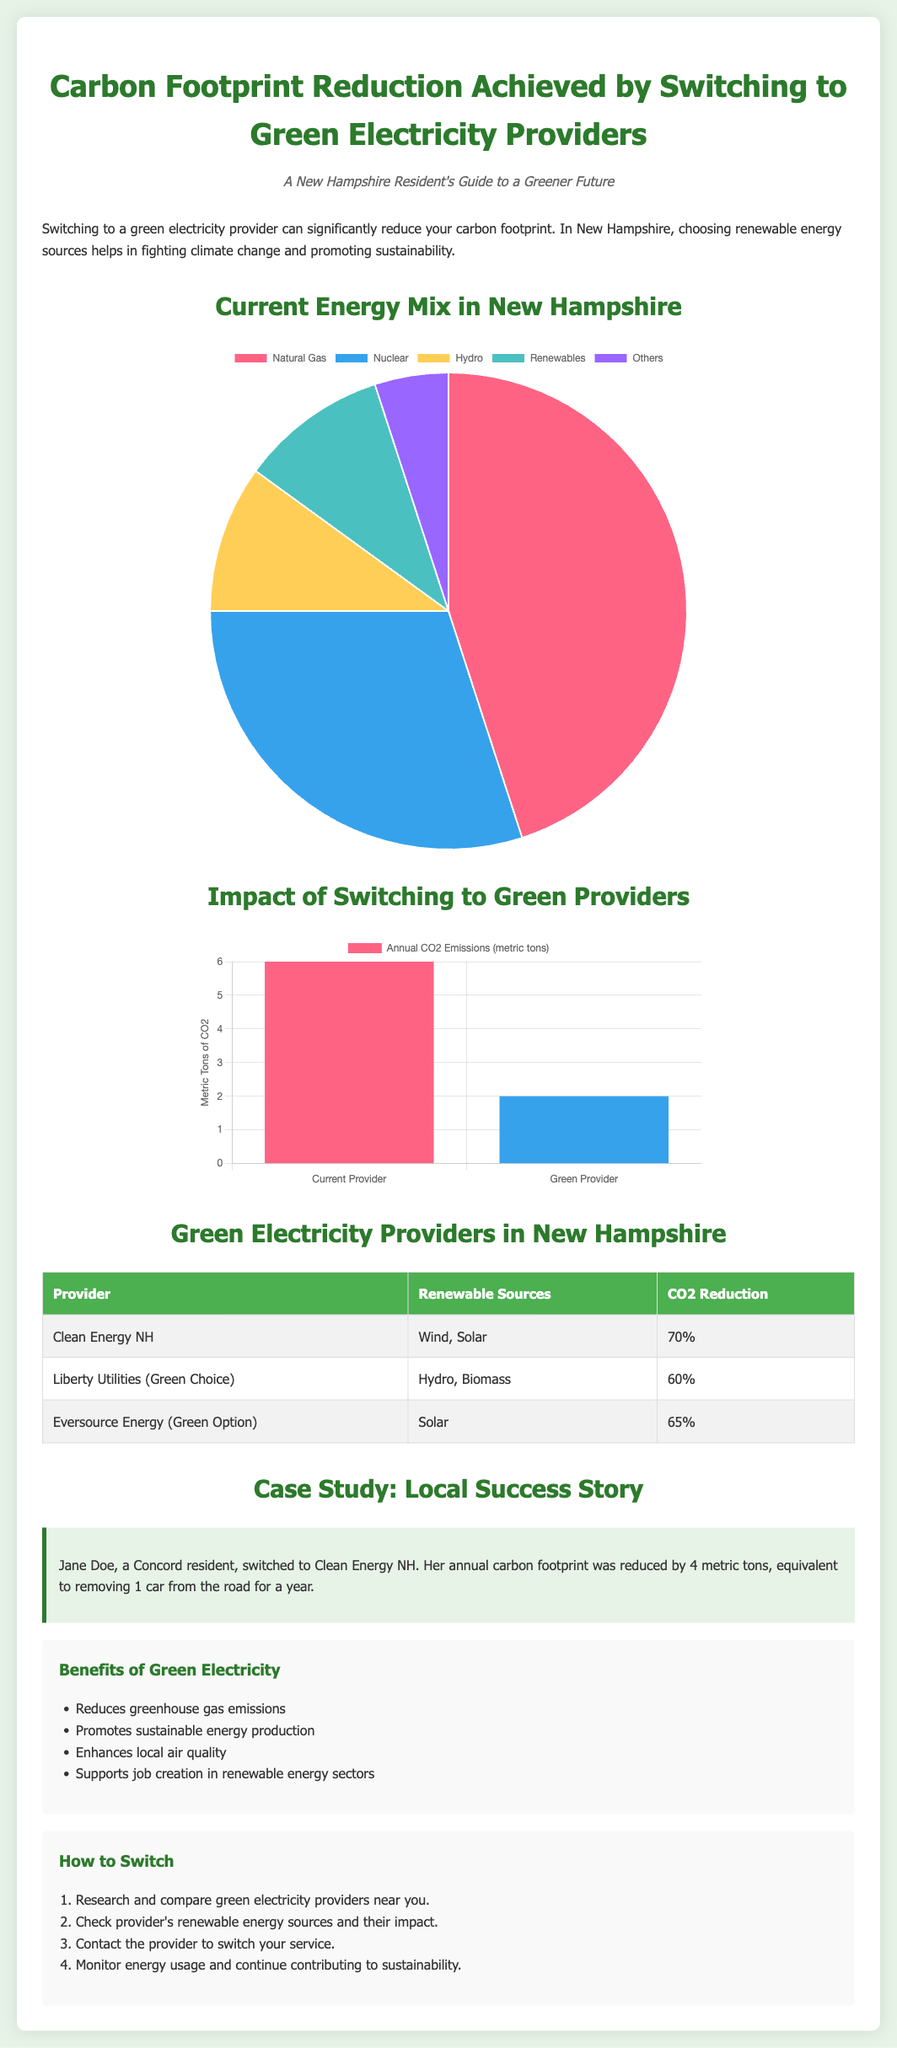What is the title of the document? The title of the document is specified at the beginning as per the HTML structure.
Answer: Carbon Footprint Reduction Achieved by Switching to Green Electricity Providers What percentage CO2 reduction does Clean Energy NH offer? The percentage CO2 reduction for Clean Energy NH is found in the table listing green electricity providers.
Answer: 70% What is the annual CO2 emission for a Green Provider? The annual CO2 emission for a Green Provider is shown in the emissions chart, comparing it to the current provider.
Answer: 2 What renewable sources does Liberty Utilities use? The renewable sources for Liberty Utilities are listed in the table of green electricity providers.
Answer: Hydro, Biomass Which case study is mentioned in the document? The document includes a localized case study of a resident who switched providers.
Answer: Jane Doe How much is Jane Doe's carbon footprint reduced after switching? Jane Doe's carbon footprint reduction is explicitly stated in the case study section of the document.
Answer: 4 metric tons What type of chart is used for the Current Energy Mix? The type of chart for the Current Energy Mix is indicated in the Chart.js setup within the document.
Answer: Pie What is the background color for the benefits section? The background color for the benefits section is stated in the CSS styling applied to that section.
Answer: #f9f9f9 What is the total percentage of renewable energy sources in New Hampshire? The total percentage of renewable sources is represented in the Current Energy Mix pie chart data.
Answer: 10% 